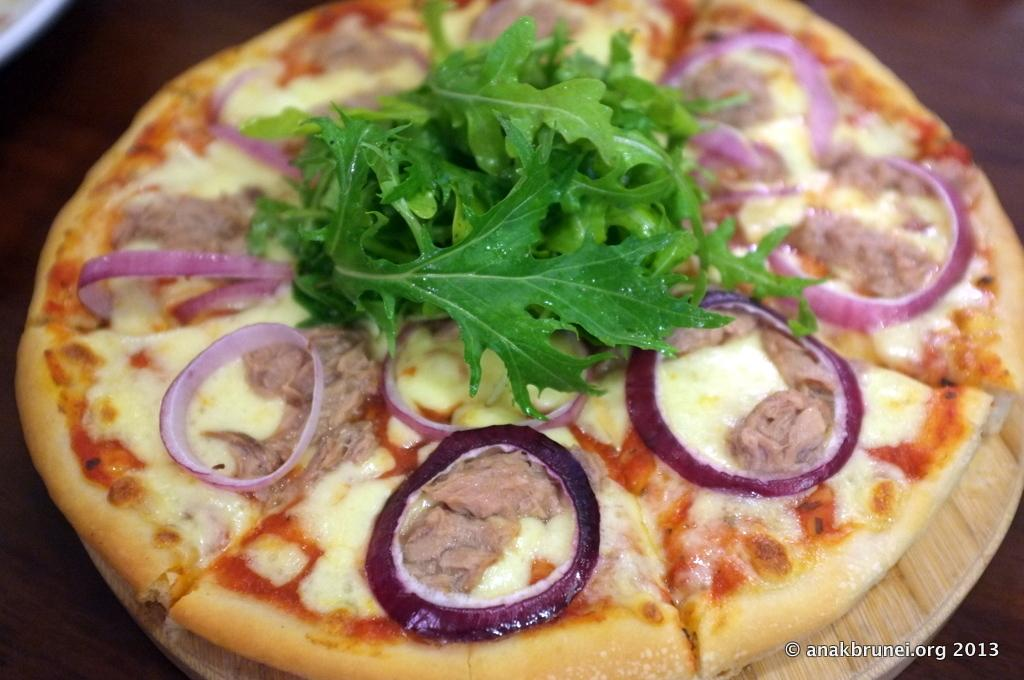What is the main object on the table in the image? There is a pizza on the table in the image. What else can be seen on the table besides the pizza? Unfortunately, the provided facts do not mention any other objects on the table. Where is the text located in the image? The text is in the bottom right corner of the image. How many houses can be seen in the image? There are no houses visible in the image. What type of feather is used as a decoration on the pizza? There is no feather present on the pizza or in the image. 